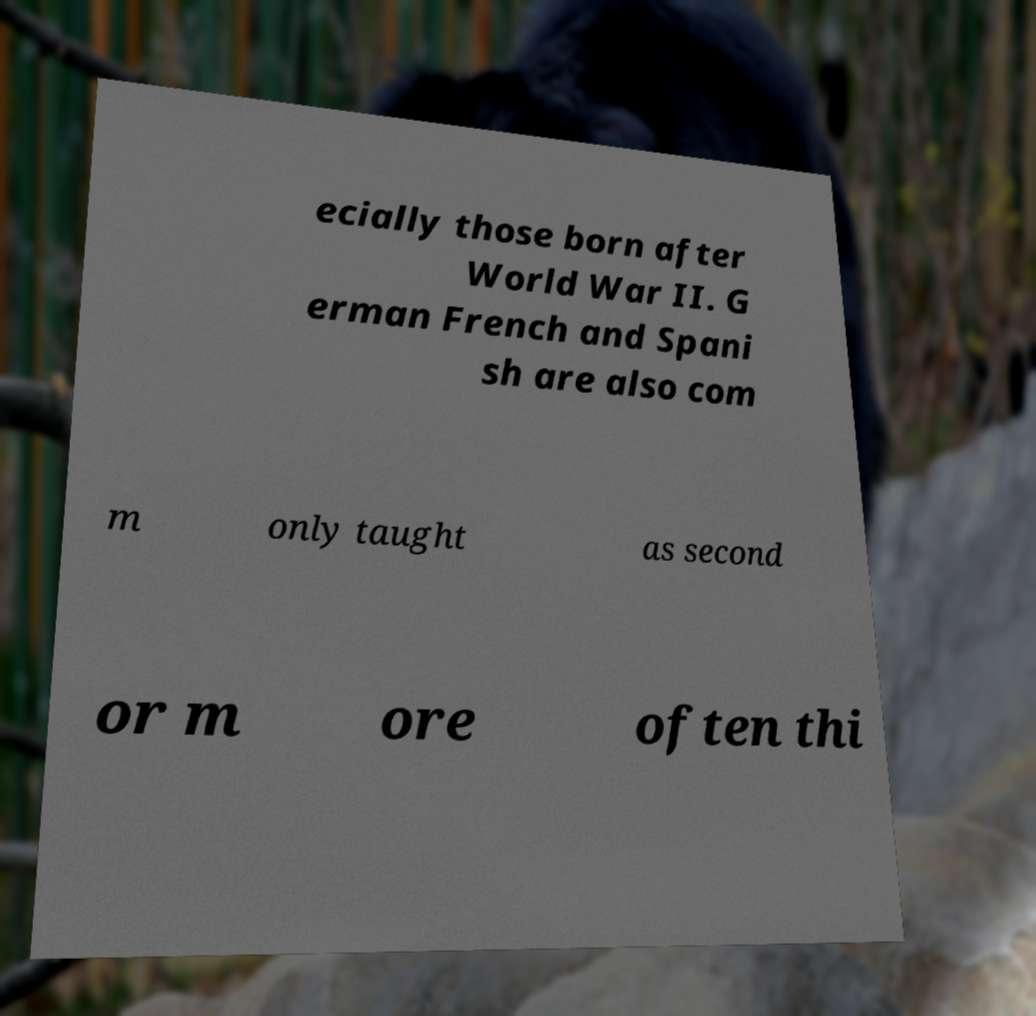Could you extract and type out the text from this image? ecially those born after World War II. G erman French and Spani sh are also com m only taught as second or m ore often thi 